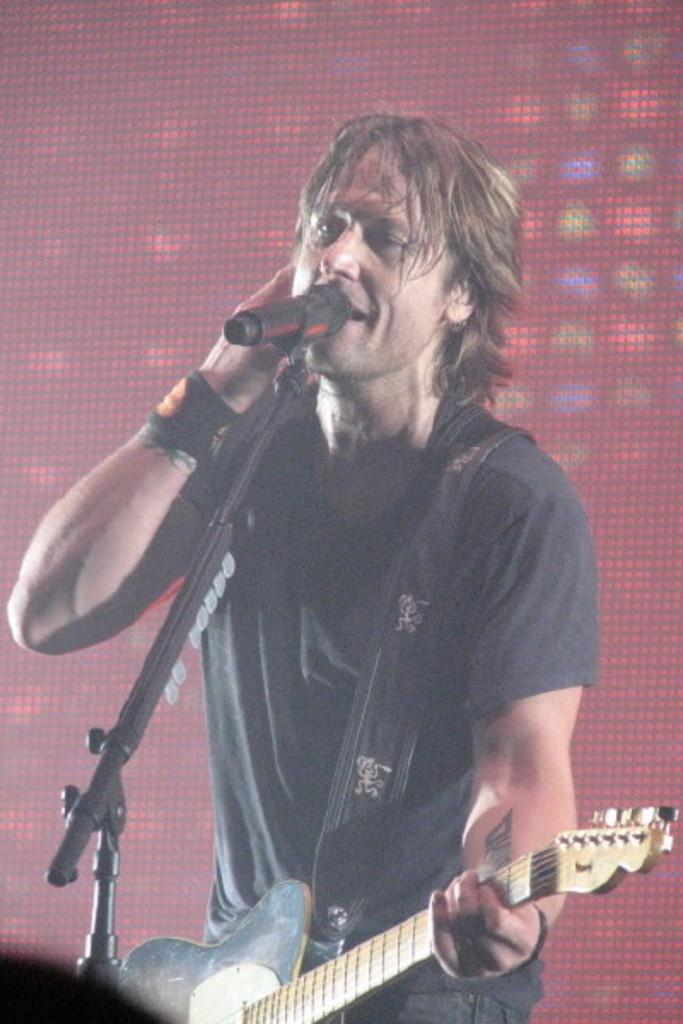Who is the main subject in the image? There is a man in the image. What is the man wearing? The man is wearing a t-shirt. What is the man holding in the image? The man is holding a guitar. What activity is the man engaged in? The man is singing on a microphone. What can be seen in the background of the image? There is a screen or banner visible in the background. What type of locket is hanging from the guitar in the image? There is no locket hanging from the guitar in the image. How does the snow affect the man's performance in the image? There is no snow present in the image, so it does not affect the man's performance. 